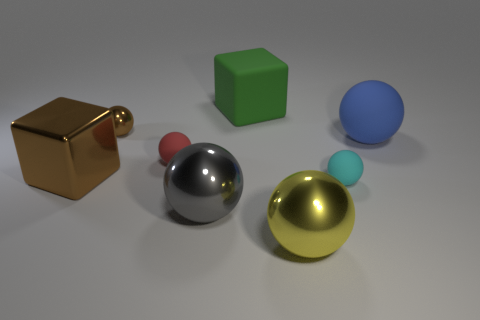Can you describe the textures of the objects and how these contribute to the overall visual effect of the image? Certainly! The objects display a range of textures: the gold cube is glossy, offering a sharp reflection, whereas the green cube appears matte and diffuses light evenly. The combination of textures creates a visually engaging contrast, emphasizing the varying material properties at play. 